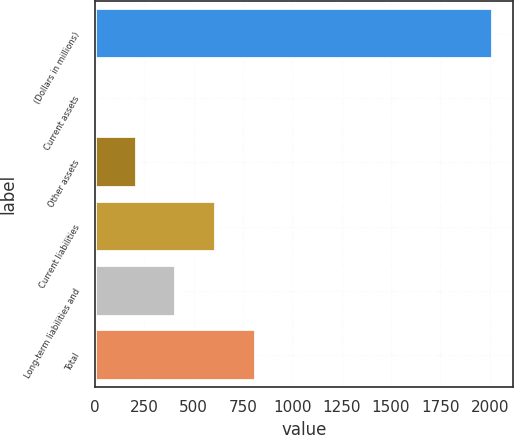<chart> <loc_0><loc_0><loc_500><loc_500><bar_chart><fcel>(Dollars in millions)<fcel>Current assets<fcel>Other assets<fcel>Current liabilities<fcel>Long-term liabilities and<fcel>Total<nl><fcel>2017<fcel>13<fcel>213.4<fcel>614.2<fcel>413.8<fcel>814.6<nl></chart> 